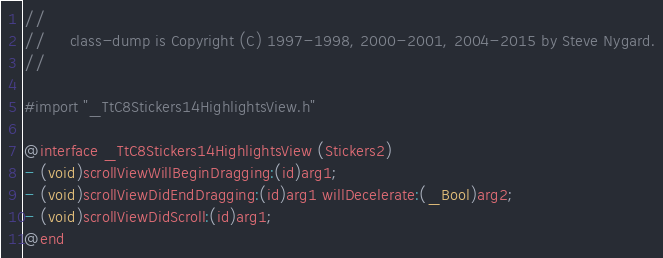Convert code to text. <code><loc_0><loc_0><loc_500><loc_500><_C_>//
//     class-dump is Copyright (C) 1997-1998, 2000-2001, 2004-2015 by Steve Nygard.
//

#import "_TtC8Stickers14HighlightsView.h"

@interface _TtC8Stickers14HighlightsView (Stickers2)
- (void)scrollViewWillBeginDragging:(id)arg1;
- (void)scrollViewDidEndDragging:(id)arg1 willDecelerate:(_Bool)arg2;
- (void)scrollViewDidScroll:(id)arg1;
@end

</code> 